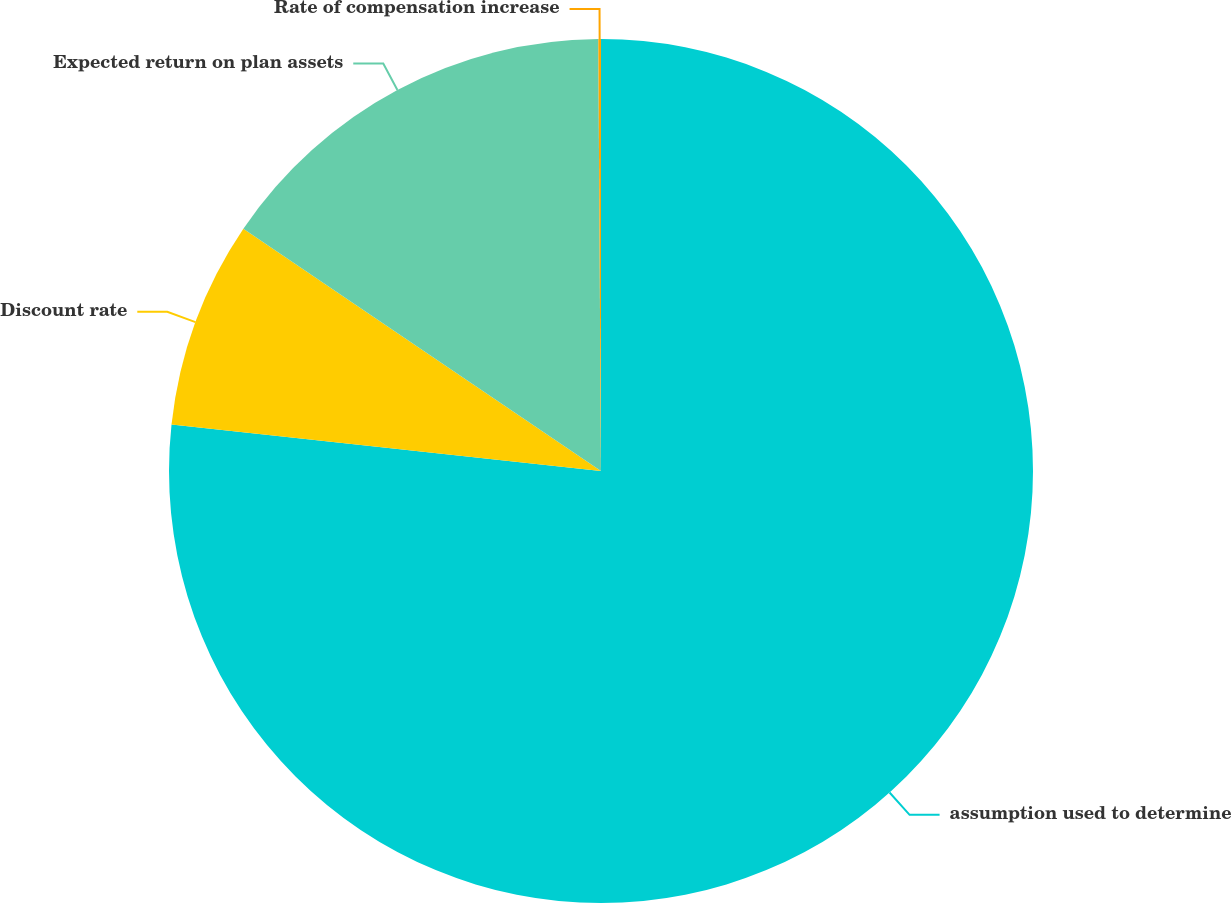Convert chart to OTSL. <chart><loc_0><loc_0><loc_500><loc_500><pie_chart><fcel>assumption used to determine<fcel>Discount rate<fcel>Expected return on plan assets<fcel>Rate of compensation increase<nl><fcel>76.71%<fcel>7.76%<fcel>15.42%<fcel>0.1%<nl></chart> 